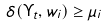<formula> <loc_0><loc_0><loc_500><loc_500>\delta ( \Upsilon _ { t } , w _ { i } ) \geq \mu _ { i }</formula> 